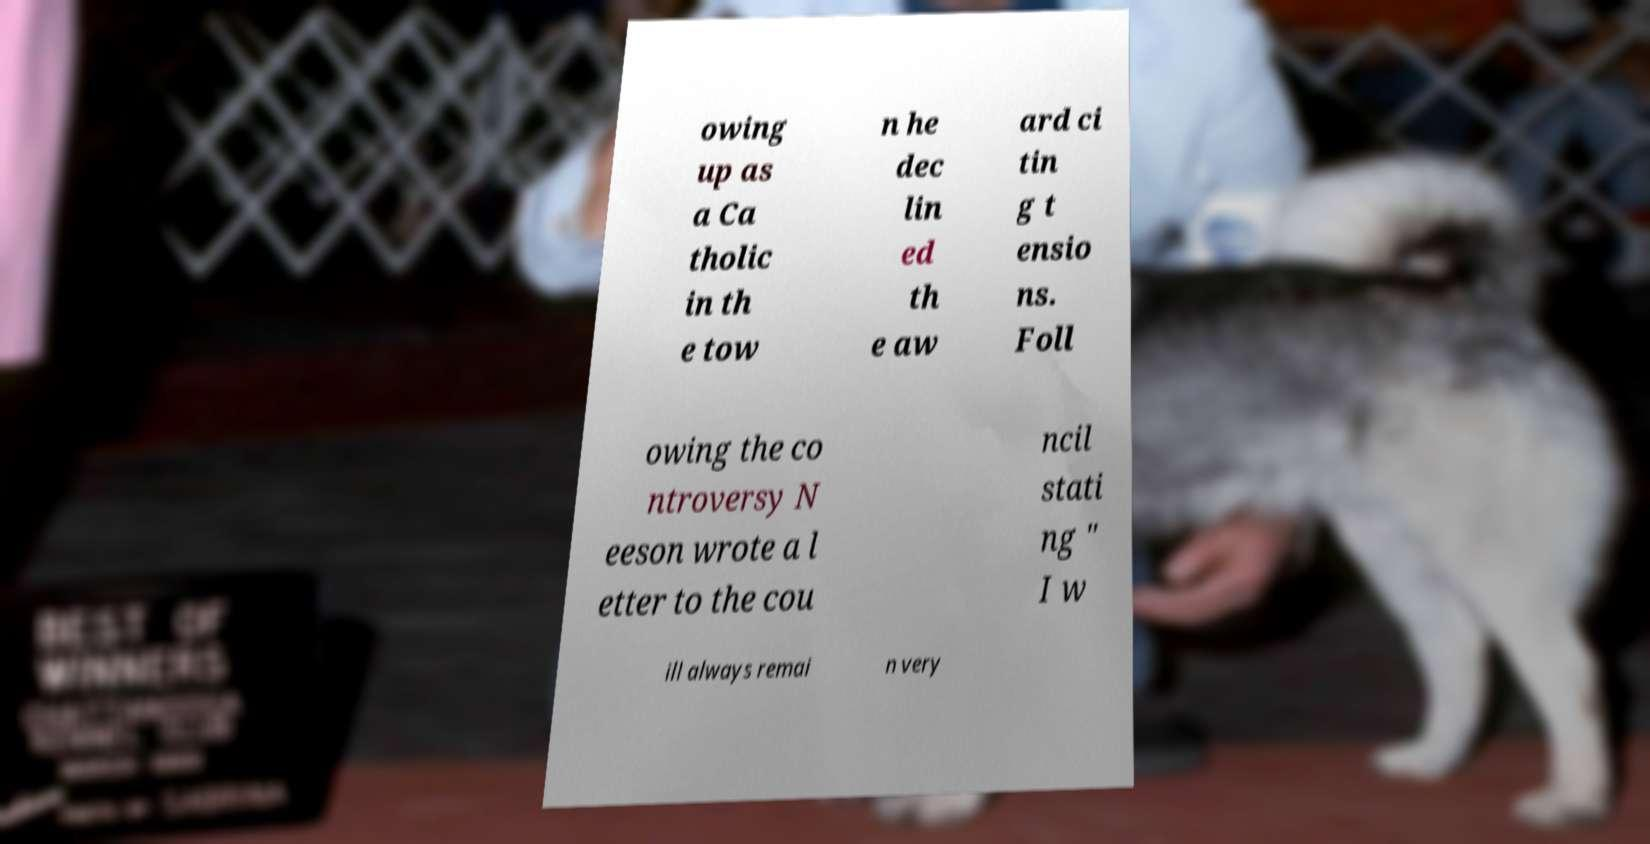Could you assist in decoding the text presented in this image and type it out clearly? owing up as a Ca tholic in th e tow n he dec lin ed th e aw ard ci tin g t ensio ns. Foll owing the co ntroversy N eeson wrote a l etter to the cou ncil stati ng " I w ill always remai n very 